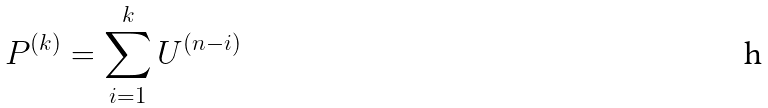Convert formula to latex. <formula><loc_0><loc_0><loc_500><loc_500>P ^ { ( k ) } = \sum _ { i = 1 } ^ { k } U ^ { ( n - i ) }</formula> 